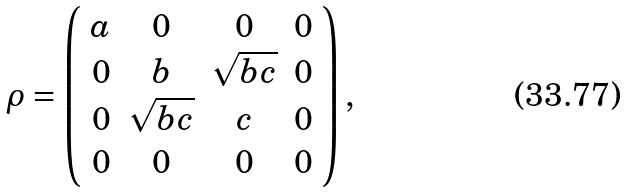<formula> <loc_0><loc_0><loc_500><loc_500>\rho = \left ( \begin{array} { c c c c } a & 0 & 0 & 0 \\ 0 & b & \sqrt { b c } & 0 \\ 0 & \sqrt { b c } & c & 0 \\ 0 & 0 & 0 & 0 \\ \end{array} \right ) ,</formula> 